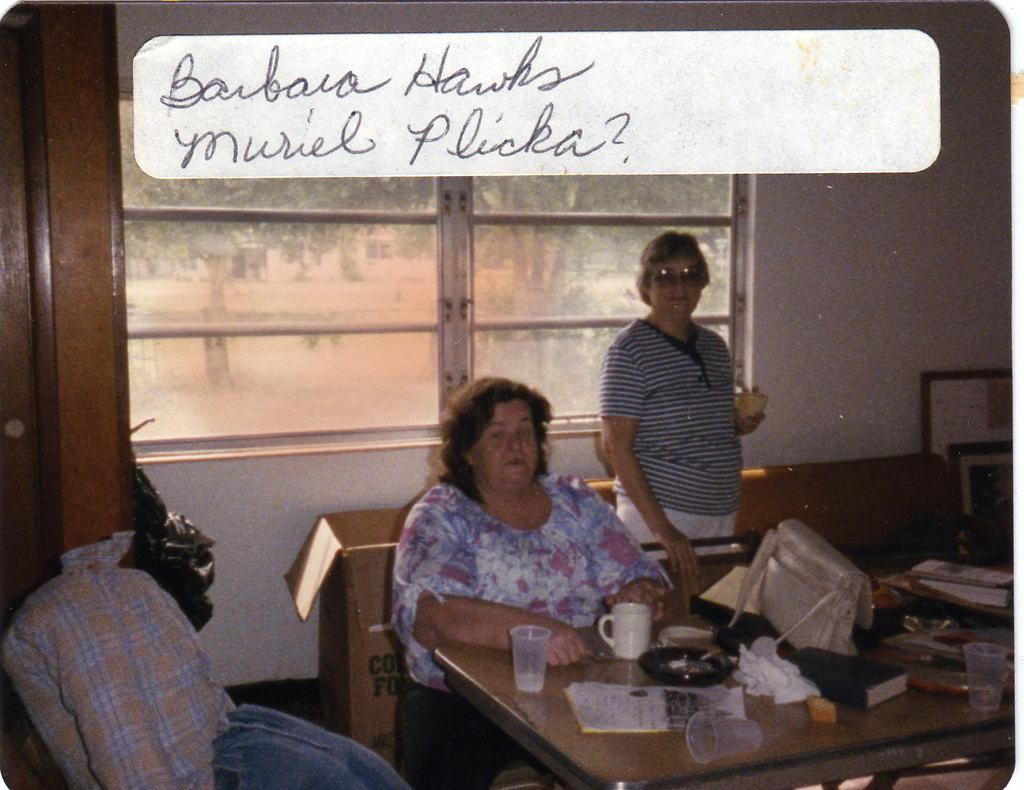Could you give a brief overview of what you see in this image? In this picture we can see woman standing and smiling wore goggle, T Shirt and here woman sitting and in front of them we have table and on table we can see glass, paper, book, bag and some more items and in the background we can see window and from window we can see trees. 